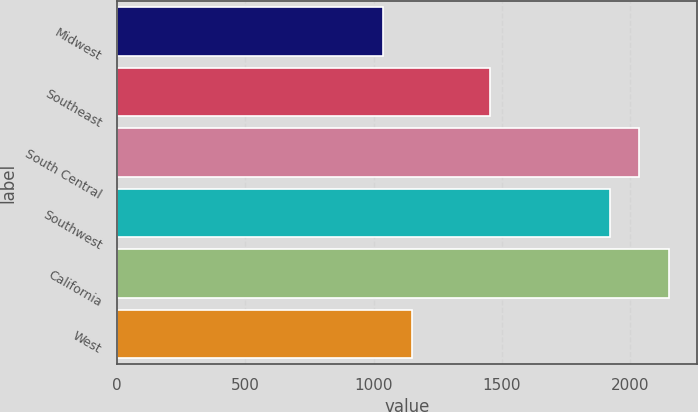<chart> <loc_0><loc_0><loc_500><loc_500><bar_chart><fcel>Midwest<fcel>Southeast<fcel>South Central<fcel>Southwest<fcel>California<fcel>West<nl><fcel>1037.1<fcel>1454.6<fcel>2032.73<fcel>1921.4<fcel>2150.4<fcel>1148.43<nl></chart> 